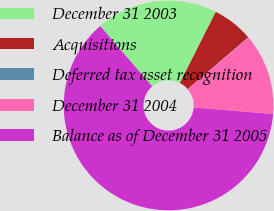Convert chart to OTSL. <chart><loc_0><loc_0><loc_500><loc_500><pie_chart><fcel>December 31 2003<fcel>Acquisitions<fcel>Deferred tax asset recognition<fcel>December 31 2004<fcel>Balance as of December 31 2005<nl><fcel>18.75%<fcel>6.29%<fcel>0.06%<fcel>12.52%<fcel>62.38%<nl></chart> 